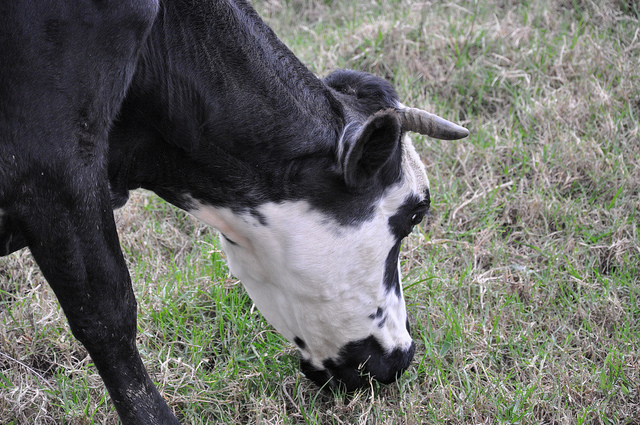<image>What color are the cows eyes reflecting? It is ambiguous to determine the color that the cow's eyes are reflecting. It could be white, black, brown, or green. What color are the cows eyes reflecting? I don't know what color are the cows eyes reflecting. It can be white, black, brown, green or none. 